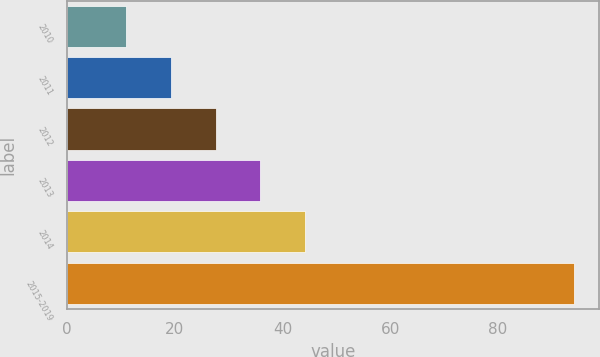Convert chart to OTSL. <chart><loc_0><loc_0><loc_500><loc_500><bar_chart><fcel>2010<fcel>2011<fcel>2012<fcel>2013<fcel>2014<fcel>2015-2019<nl><fcel>11<fcel>19.3<fcel>27.6<fcel>35.9<fcel>44.2<fcel>94<nl></chart> 